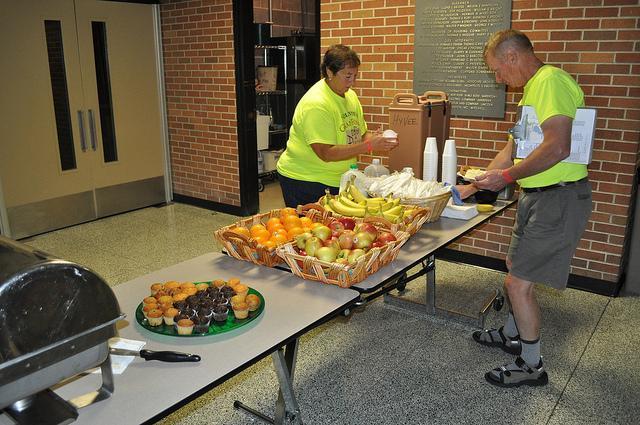How many women are in this picture?
Give a very brief answer. 1. How many people are there?
Give a very brief answer. 2. 